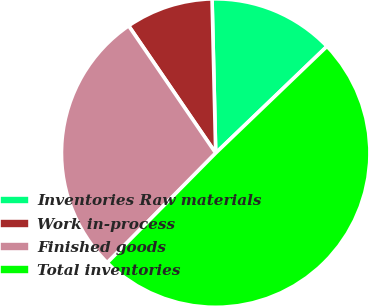Convert chart to OTSL. <chart><loc_0><loc_0><loc_500><loc_500><pie_chart><fcel>Inventories Raw materials<fcel>Work in-process<fcel>Finished goods<fcel>Total inventories<nl><fcel>13.21%<fcel>9.17%<fcel>28.04%<fcel>49.58%<nl></chart> 